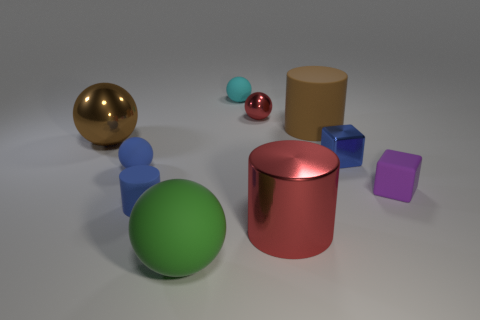There is a tiny metallic object that is the same color as the big metallic cylinder; what shape is it?
Offer a terse response. Sphere. Are there the same number of rubber balls in front of the small blue ball and large green rubber things?
Keep it short and to the point. Yes. How many red balls have the same material as the brown cylinder?
Your answer should be compact. 0. The other cylinder that is the same material as the small cylinder is what color?
Provide a succinct answer. Brown. Do the small cyan object and the large green thing have the same shape?
Provide a succinct answer. Yes. There is a rubber cylinder that is left of the big matte object right of the green rubber sphere; is there a small rubber cylinder that is on the right side of it?
Make the answer very short. No. How many spheres have the same color as the big matte cylinder?
Provide a succinct answer. 1. There is a brown metal object that is the same size as the brown matte object; what is its shape?
Provide a succinct answer. Sphere. There is a large brown metallic object; are there any small blue matte spheres behind it?
Ensure brevity in your answer.  No. Do the cyan thing and the blue cube have the same size?
Provide a succinct answer. Yes. 